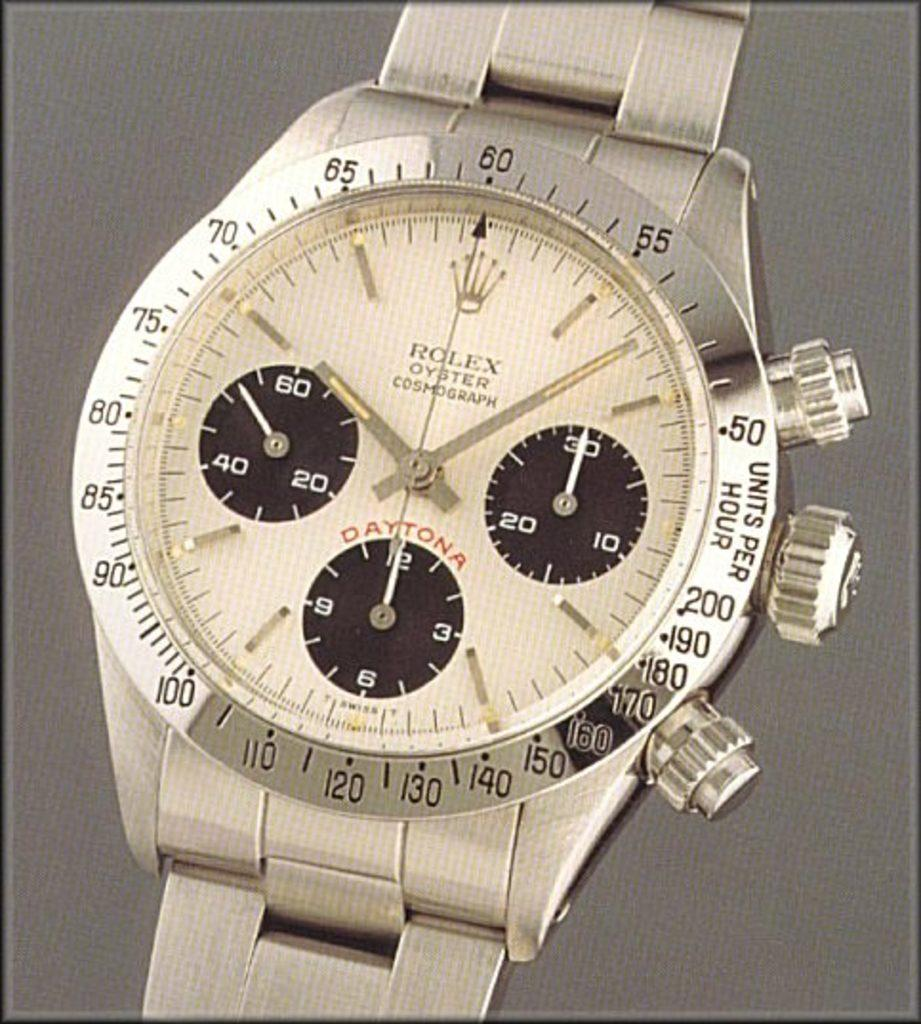<image>
Present a compact description of the photo's key features. A closeup on a platinum colored Rolex Oyster watch. 